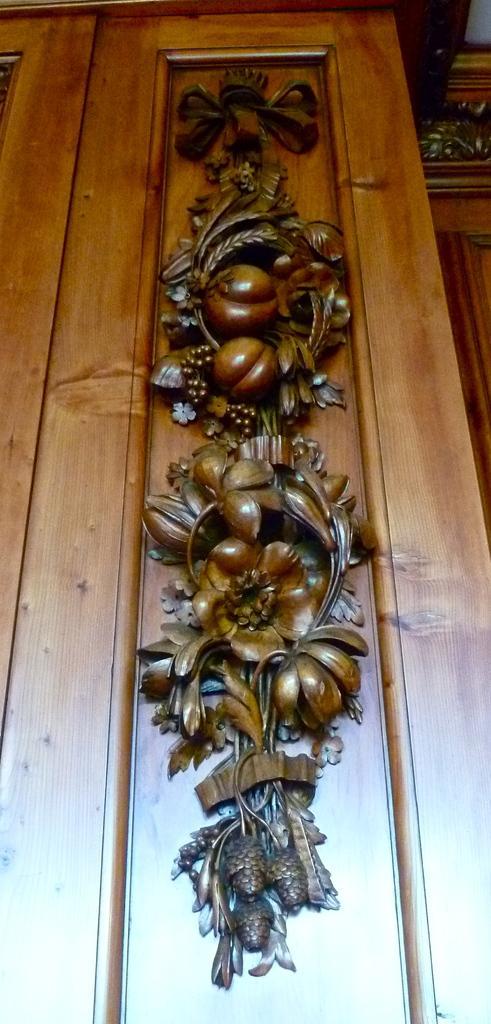How would you summarize this image in a sentence or two? In the given image i can see a design on the wooden door. 